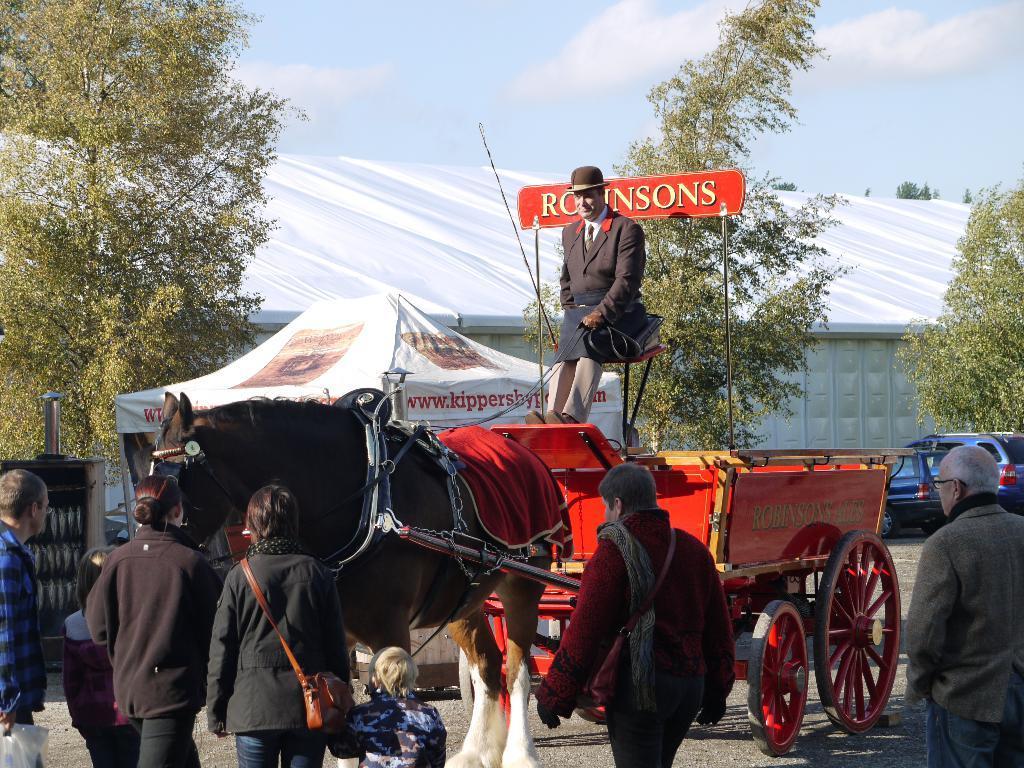Could you give a brief overview of what you see in this image? A horse with cart. This person is sitting on this cart. Far there is a tent. These are trees. This persons are standing. Far there is a vehicle. 